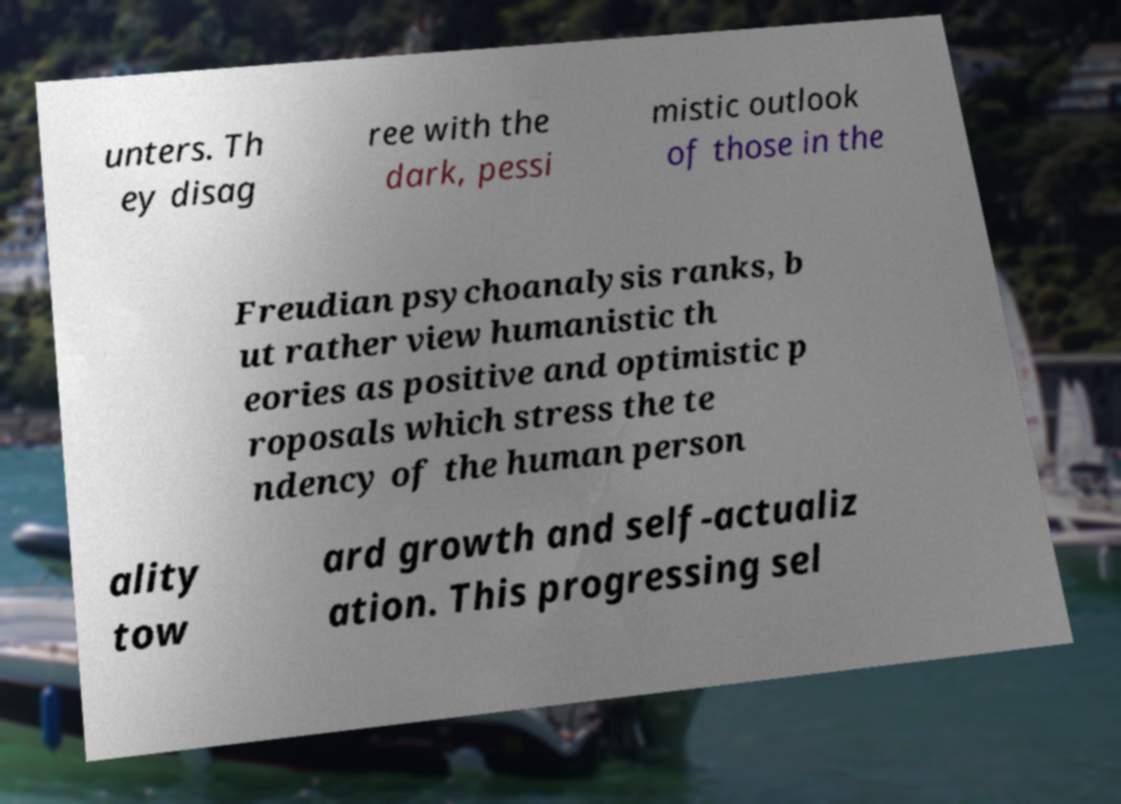Can you accurately transcribe the text from the provided image for me? unters. Th ey disag ree with the dark, pessi mistic outlook of those in the Freudian psychoanalysis ranks, b ut rather view humanistic th eories as positive and optimistic p roposals which stress the te ndency of the human person ality tow ard growth and self-actualiz ation. This progressing sel 